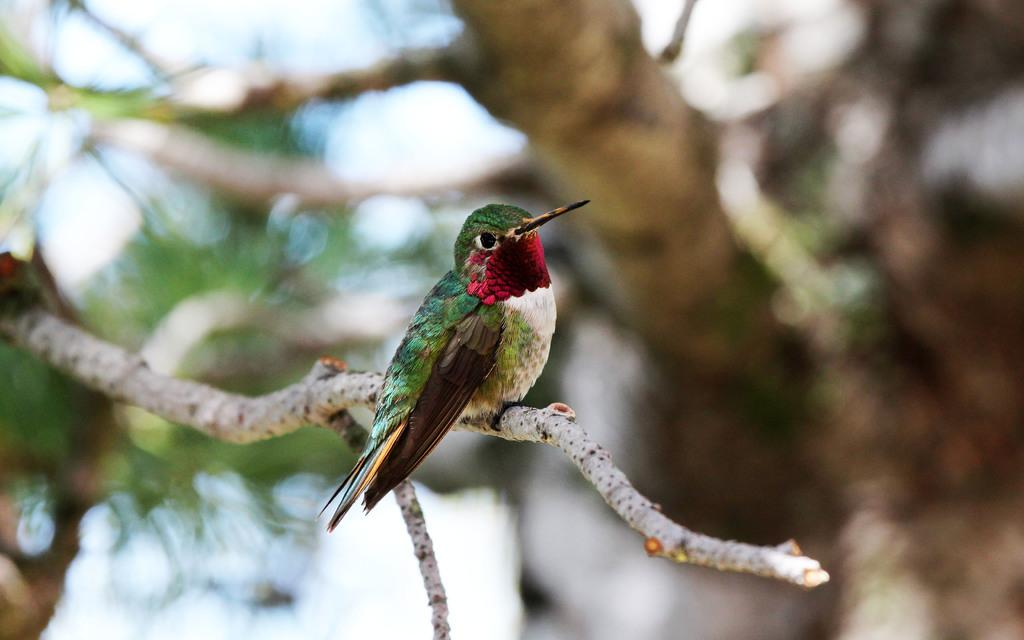What type of animal can be seen in the picture? There is a bird in the picture. Where is the bird located in the image? The bird is sitting on the stem of a tree. Can you describe the background of the image? The background of the image is slightly blurred. What type of humor can be seen in the calendar on the cow in the image? There is no calendar or cow present in the image; it features a bird sitting on the stem of a tree with a slightly blurred background. 